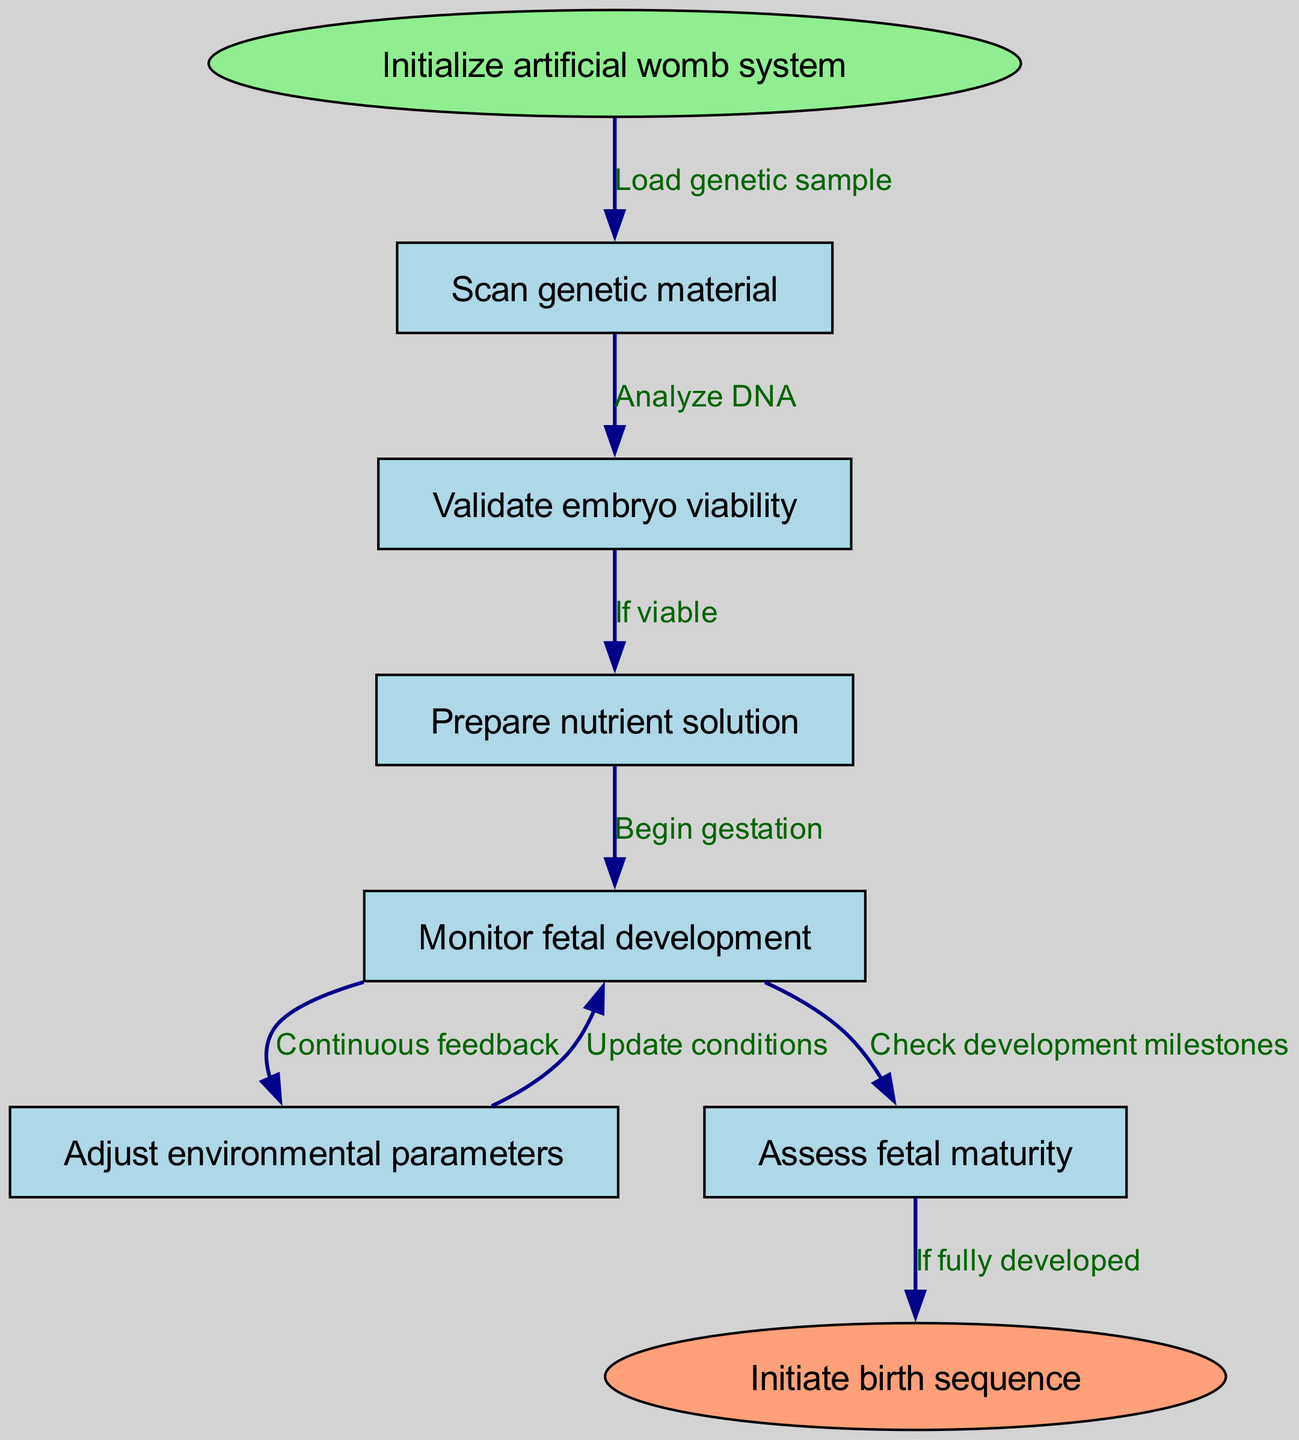What is the first step in the artificial womb system? The first step is indicated in the 'start' node, which is to 'Initialize artificial womb system'. This node is the entry point of the diagram and is connected by an edge from the 'start' node to the 'scan' node.
Answer: Initialize artificial womb system How many nodes are there in the diagram? Counting the nodes listed in the 'nodes' data section results in a total of eight distinct nodes: start, scan, validate, prepare, monitor, adjust, mature, and end.
Answer: Eight What does the edge labeled "Load genetic sample" connect? The edge labeled "Load genetic sample" connects the 'start' node to the 'scan' node, indicating the action taken after initializing the system. This connection establishes a flow from the start of the process to scanning the genetic material.
Answer: Start and scan What condition must be met according to the "If viable" edge? According to the "If viable" edge, the condition that must be met is that the embryo must be considered viable after the validation step before proceeding to prepare the nutrient solution. This decision leads to the next step of preparation for gestation.
Answer: Viable embryo What is the final action indicated in the flowchart? The flowchart concludes with the action defined in the 'end' node, which is to 'Initiate birth sequence'. This represents the ultimate goal after completing all previous steps in the process.
Answer: Initiate birth sequence How do you transition from monitoring to adjusting conditions? The transition from monitoring to adjusting conditions is indicated by the edge labeled "Continuous feedback", which signifies that there is an ongoing evaluation during the monitoring phase that prompts necessary adjustments to environmental parameters as needed.
Answer: Continuous feedback What needs to be checked before ending the process? Before ending the process, the 'mature' node indicates that fetal maturity needs to be assessed to ensure that all requirements for a successful birth sequence have been met. This step verifies the development status before proceeding to birth.
Answer: Fetal maturity How often are environmental parameters updated during the process? Environmental parameters are updated continuously during the process, as indicated by the edge labeled "Update conditions" that flows back from the 'adjust' node to the 'monitor' node. This reflects the cyclical nature of monitoring and adjusting throughout fetal development.
Answer: Continuously What happens after preparing the nutrient solution? After preparing the nutrient solution, the flowchart indicates that the next step is to 'Begin gestation', connecting the preparation of nutrients directly to the start of the gestational phase. This shows the progression from preparation to the actual growth phase.
Answer: Begin gestation 